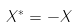Convert formula to latex. <formula><loc_0><loc_0><loc_500><loc_500>X ^ { * } = - X</formula> 